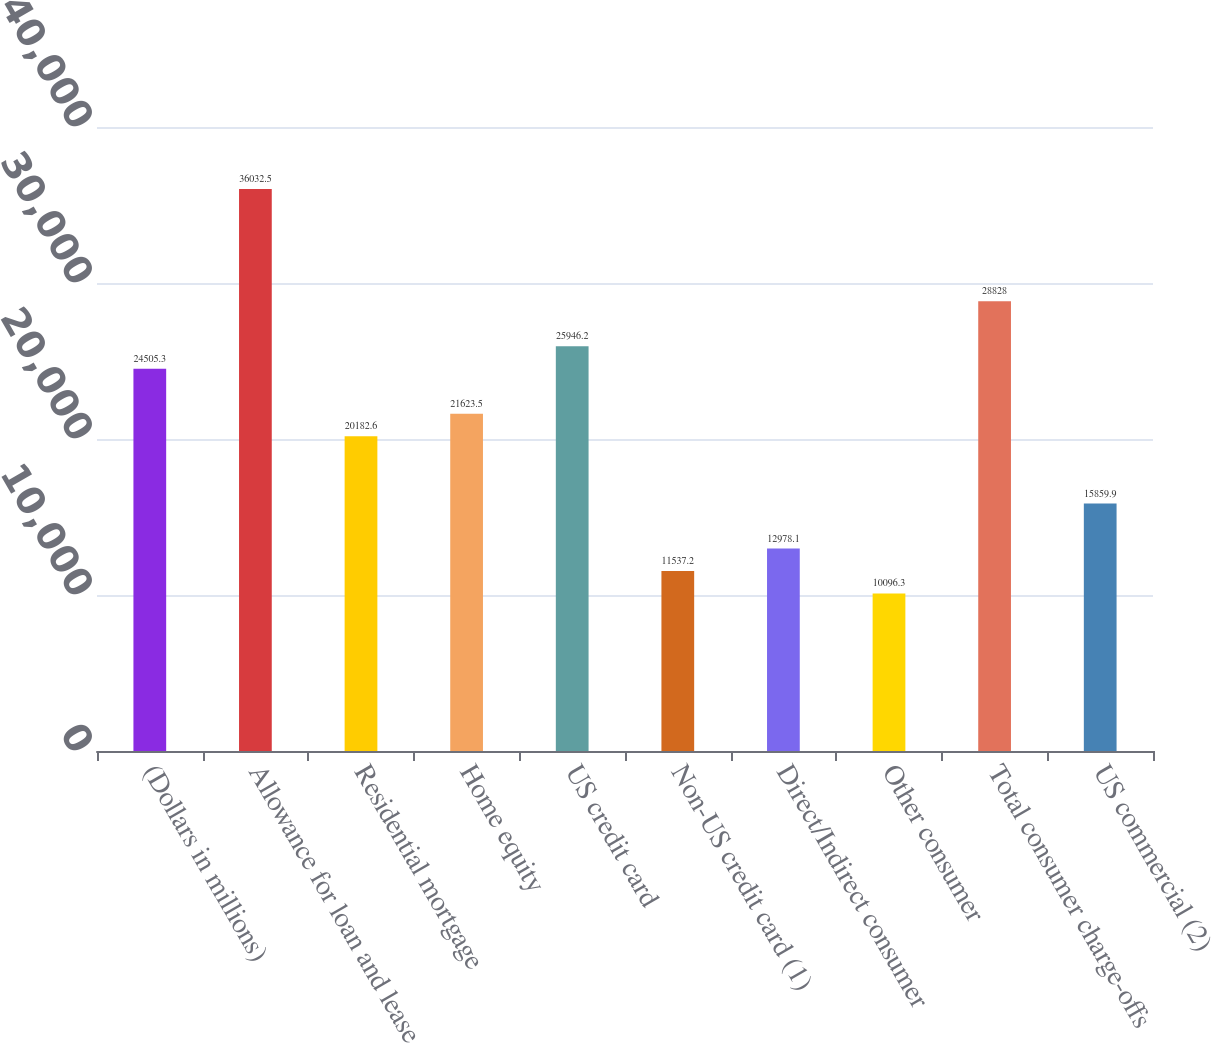Convert chart. <chart><loc_0><loc_0><loc_500><loc_500><bar_chart><fcel>(Dollars in millions)<fcel>Allowance for loan and lease<fcel>Residential mortgage<fcel>Home equity<fcel>US credit card<fcel>Non-US credit card (1)<fcel>Direct/Indirect consumer<fcel>Other consumer<fcel>Total consumer charge-offs<fcel>US commercial (2)<nl><fcel>24505.3<fcel>36032.5<fcel>20182.6<fcel>21623.5<fcel>25946.2<fcel>11537.2<fcel>12978.1<fcel>10096.3<fcel>28828<fcel>15859.9<nl></chart> 